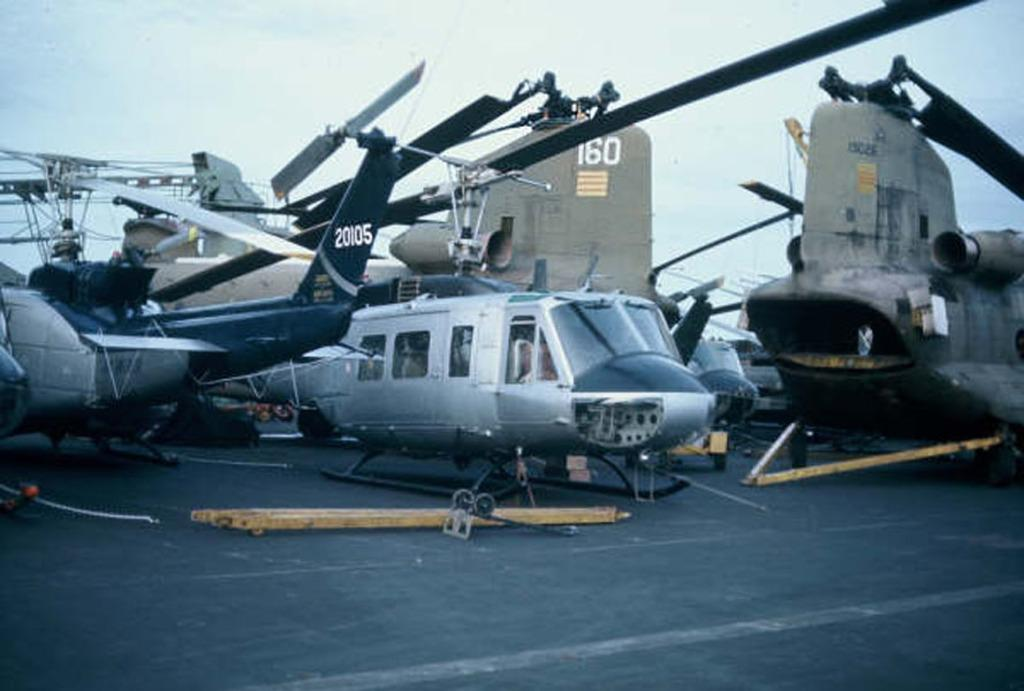<image>
Give a short and clear explanation of the subsequent image. A number of helicopters are on a deck and one has the number 20105 on its tail. 